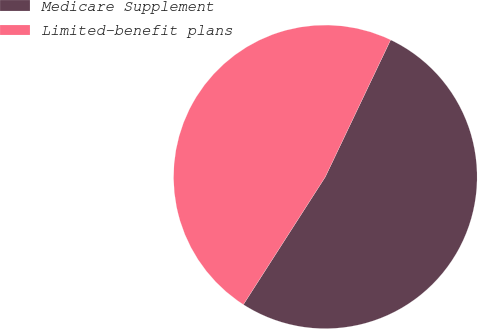Convert chart to OTSL. <chart><loc_0><loc_0><loc_500><loc_500><pie_chart><fcel>Medicare Supplement<fcel>Limited-benefit plans<nl><fcel>52.0%<fcel>48.0%<nl></chart> 